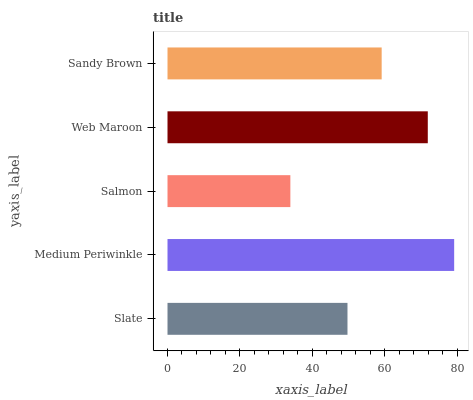Is Salmon the minimum?
Answer yes or no. Yes. Is Medium Periwinkle the maximum?
Answer yes or no. Yes. Is Medium Periwinkle the minimum?
Answer yes or no. No. Is Salmon the maximum?
Answer yes or no. No. Is Medium Periwinkle greater than Salmon?
Answer yes or no. Yes. Is Salmon less than Medium Periwinkle?
Answer yes or no. Yes. Is Salmon greater than Medium Periwinkle?
Answer yes or no. No. Is Medium Periwinkle less than Salmon?
Answer yes or no. No. Is Sandy Brown the high median?
Answer yes or no. Yes. Is Sandy Brown the low median?
Answer yes or no. Yes. Is Slate the high median?
Answer yes or no. No. Is Salmon the low median?
Answer yes or no. No. 